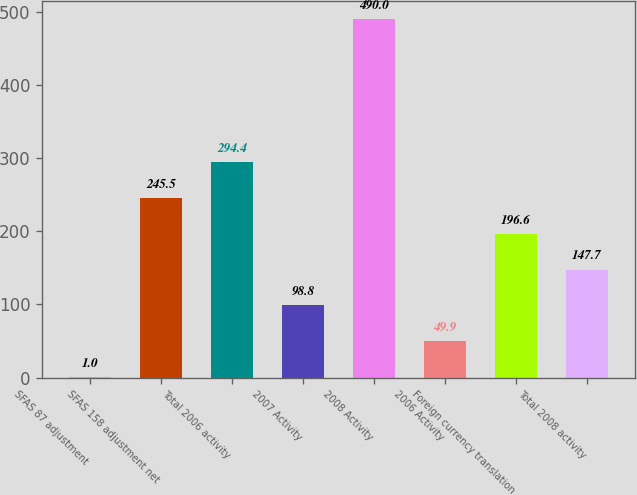<chart> <loc_0><loc_0><loc_500><loc_500><bar_chart><fcel>SFAS 87 adjustment<fcel>SFAS 158 adjustment net<fcel>Total 2006 activity<fcel>2007 Activity<fcel>2008 Activity<fcel>2006 Activity<fcel>Foreign currency translation<fcel>Total 2008 activity<nl><fcel>1<fcel>245.5<fcel>294.4<fcel>98.8<fcel>490<fcel>49.9<fcel>196.6<fcel>147.7<nl></chart> 